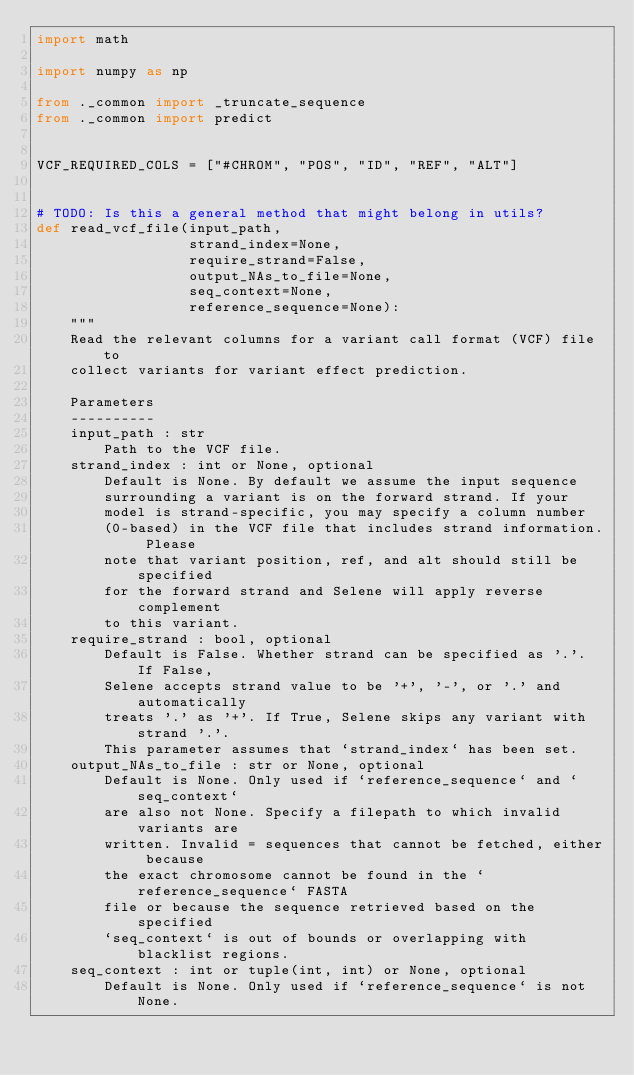Convert code to text. <code><loc_0><loc_0><loc_500><loc_500><_Python_>import math

import numpy as np

from ._common import _truncate_sequence
from ._common import predict


VCF_REQUIRED_COLS = ["#CHROM", "POS", "ID", "REF", "ALT"]


# TODO: Is this a general method that might belong in utils?
def read_vcf_file(input_path,
                  strand_index=None,
                  require_strand=False,
                  output_NAs_to_file=None,
                  seq_context=None,
                  reference_sequence=None):
    """
    Read the relevant columns for a variant call format (VCF) file to
    collect variants for variant effect prediction.

    Parameters
    ----------
    input_path : str
        Path to the VCF file.
    strand_index : int or None, optional
        Default is None. By default we assume the input sequence
        surrounding a variant is on the forward strand. If your
        model is strand-specific, you may specify a column number
        (0-based) in the VCF file that includes strand information. Please
        note that variant position, ref, and alt should still be specified
        for the forward strand and Selene will apply reverse complement
        to this variant.
    require_strand : bool, optional
        Default is False. Whether strand can be specified as '.'. If False,
        Selene accepts strand value to be '+', '-', or '.' and automatically
        treats '.' as '+'. If True, Selene skips any variant with strand '.'.
        This parameter assumes that `strand_index` has been set.
    output_NAs_to_file : str or None, optional
        Default is None. Only used if `reference_sequence` and `seq_context`
        are also not None. Specify a filepath to which invalid variants are
        written. Invalid = sequences that cannot be fetched, either because
        the exact chromosome cannot be found in the `reference_sequence` FASTA
        file or because the sequence retrieved based on the specified
        `seq_context` is out of bounds or overlapping with blacklist regions.
    seq_context : int or tuple(int, int) or None, optional
        Default is None. Only used if `reference_sequence` is not None.</code> 